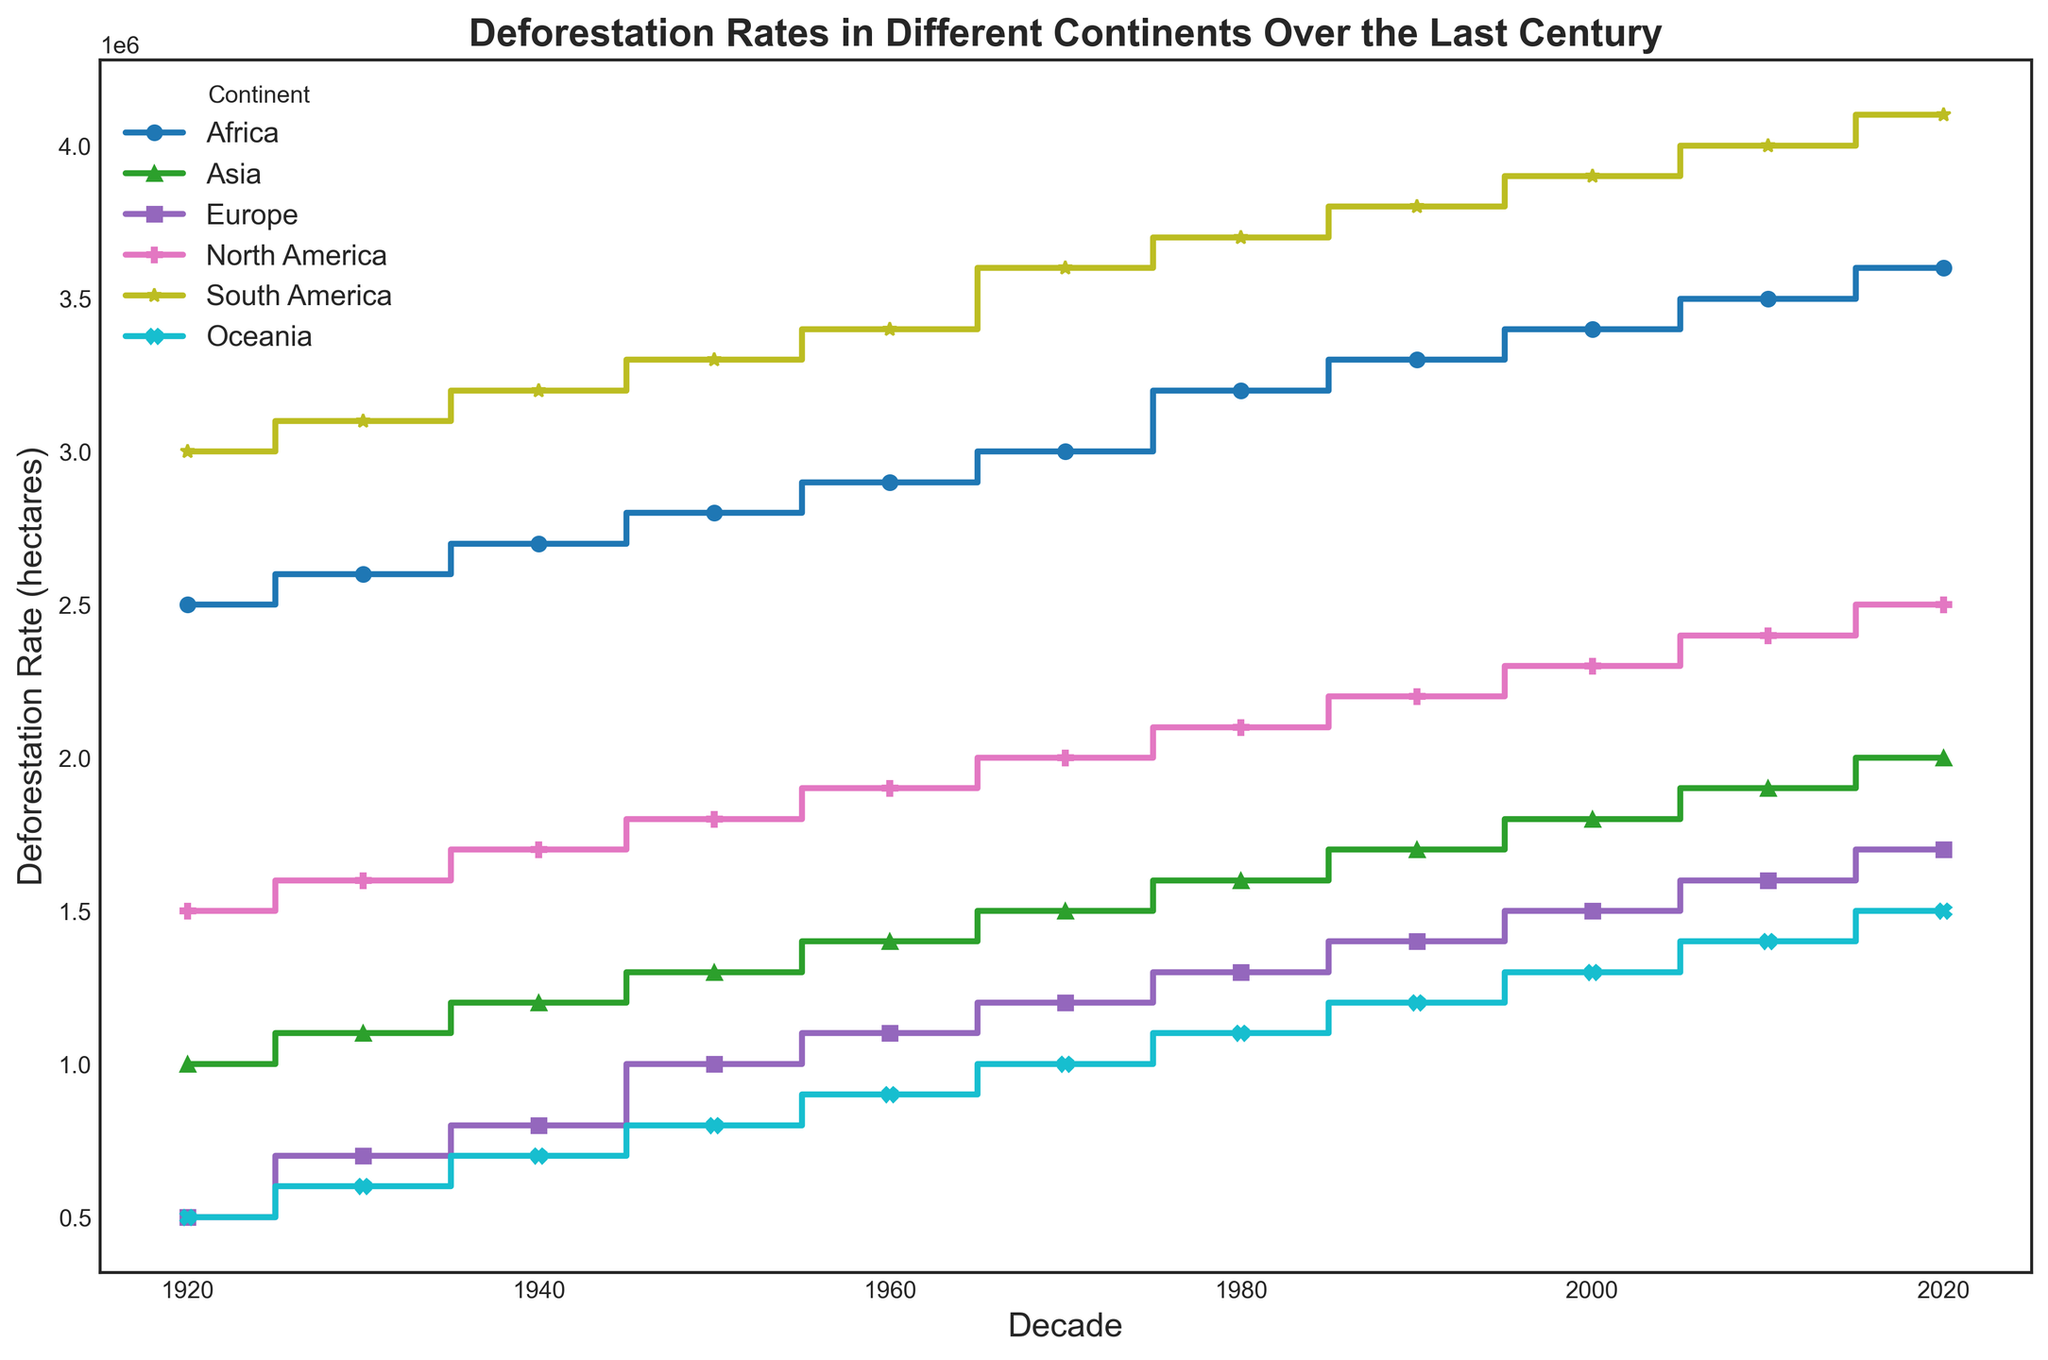Which continent had the highest deforestation rate in 2020? Looking at the plot, the continent with the highest deforestation rate in 2020 is South America, since its line is at the highest vertical position at 4100000 hectares.
Answer: South America Between 1950 and 1960, which continent had the greatest increase in deforestation rate? To determine this, compare the vertical jumps in the lines between 1950 and 1960. South America shows the highest increase, as its deforestation rate jumps from 3300000 to 3400000 hectares, an increase of 100000 hectares.
Answer: South America By how much did Africa's deforestation rate increase from 1980 to 2020? To find this, identify the deforestation rates for Africa in 1980 and 2020 from the plot, which are 3200000 and 3600000 hectares respectively. The increase is 3600000 - 3200000 = 400000 hectares.
Answer: 400000 hectares Which two continents had nearly equal deforestation rates in the 1940s, and what were their rates? Observing the plot, Europe and Oceania had nearly equal deforestation rates in the 1940s, both around 700000 hectares. Their lines are very close and almost overlap at this period.
Answer: Europe and Oceania at 700000 hectares What is the trend of Asia's deforestation rate over the century, and how does it compare with Africa's trend? Both Asia and Africa show a steadily increasing trend in deforestation rates across the century. However, Africa's rate consistently remains higher than Asia's, as evidenced by Africa's higher line on the plot.
Answer: Both increase, Africa higher In which decade did North America's deforestation rate surpass 2000000 hectares? Look at the North America line and note the first decade where it goes above the 2000000-hectare mark. It surpasses it in the 1970s.
Answer: 1970s Calculate the average deforestation rate for Europe between 1920 and 2020. Extracting the decade values for Europe and averaging them: (500000 + 700000 + 800000 + 1000000 + 1100000 + 1200000 + 1300000 + 1400000 + 1500000 + 1600000 + 1700000) / 11 = 1090909 hectares.
Answer: 1090909 hectares 